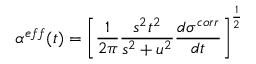<formula> <loc_0><loc_0><loc_500><loc_500>\alpha ^ { e f f } ( t ) = \left [ \frac { 1 } { 2 \pi } \frac { s ^ { 2 } t ^ { 2 } } { s ^ { 2 } + u ^ { 2 } } \frac { d \sigma ^ { c o r r } } { d t } \right ] ^ { \frac { 1 } { 2 } }</formula> 